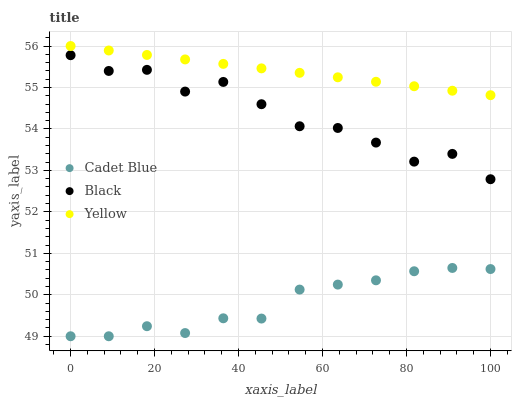Does Cadet Blue have the minimum area under the curve?
Answer yes or no. Yes. Does Yellow have the maximum area under the curve?
Answer yes or no. Yes. Does Black have the minimum area under the curve?
Answer yes or no. No. Does Black have the maximum area under the curve?
Answer yes or no. No. Is Yellow the smoothest?
Answer yes or no. Yes. Is Black the roughest?
Answer yes or no. Yes. Is Black the smoothest?
Answer yes or no. No. Is Yellow the roughest?
Answer yes or no. No. Does Cadet Blue have the lowest value?
Answer yes or no. Yes. Does Black have the lowest value?
Answer yes or no. No. Does Yellow have the highest value?
Answer yes or no. Yes. Does Black have the highest value?
Answer yes or no. No. Is Cadet Blue less than Yellow?
Answer yes or no. Yes. Is Yellow greater than Cadet Blue?
Answer yes or no. Yes. Does Cadet Blue intersect Yellow?
Answer yes or no. No. 